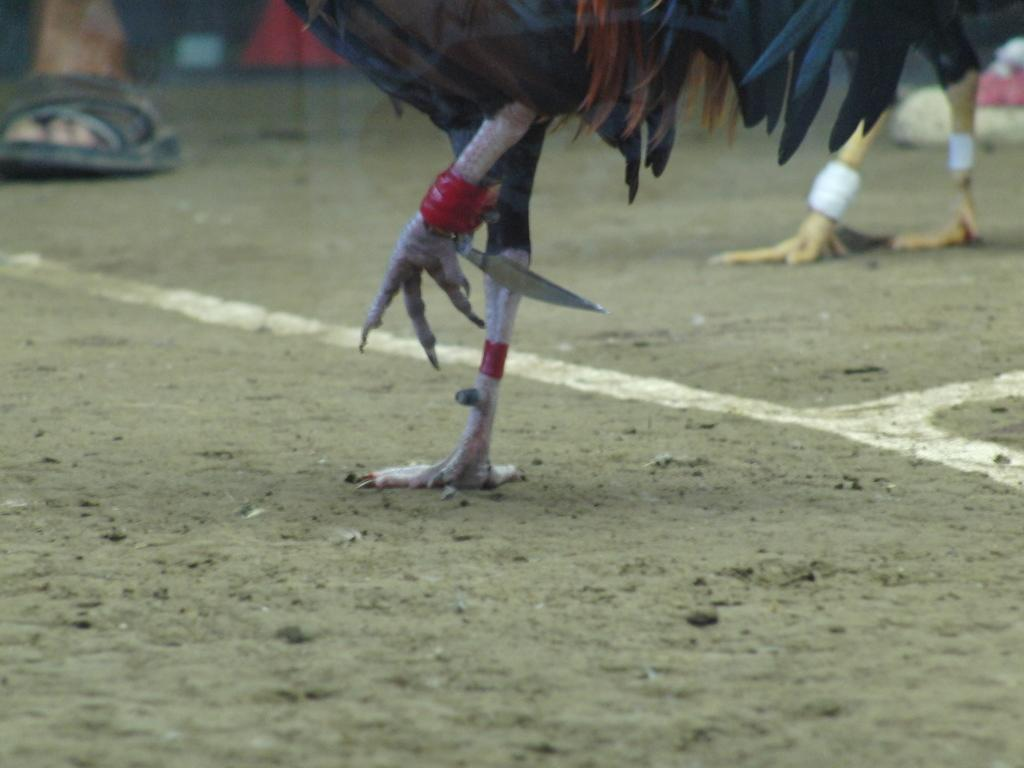What object is present in the image that could be used for cutting? There is a knife in the image. What is the knife positioned near in the image? The knife is near a cock's legs. Can you describe anything visible in the background of the image? There is a person's foot visible in the background of the image. What type of wilderness can be seen in the image? There is no wilderness present in the image; it features a knife near a cock's legs and a person's foot in the background. What size is the sheet used to cover the cock in the image? There is no sheet present in the image, and the cock's legs are not covered. 